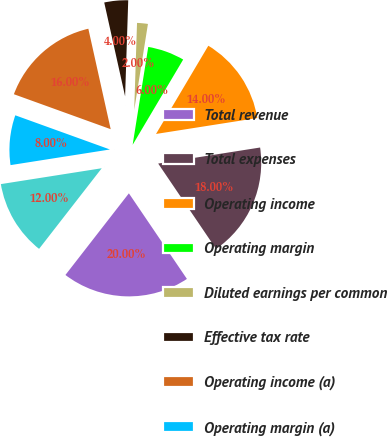<chart> <loc_0><loc_0><loc_500><loc_500><pie_chart><fcel>Total revenue<fcel>Total expenses<fcel>Operating income<fcel>Operating margin<fcel>Diluted earnings per common<fcel>Effective tax rate<fcel>Operating income (a)<fcel>Operating margin (a)<fcel>Net income attributable to<nl><fcel>20.0%<fcel>18.0%<fcel>14.0%<fcel>6.0%<fcel>2.0%<fcel>4.0%<fcel>16.0%<fcel>8.0%<fcel>12.0%<nl></chart> 